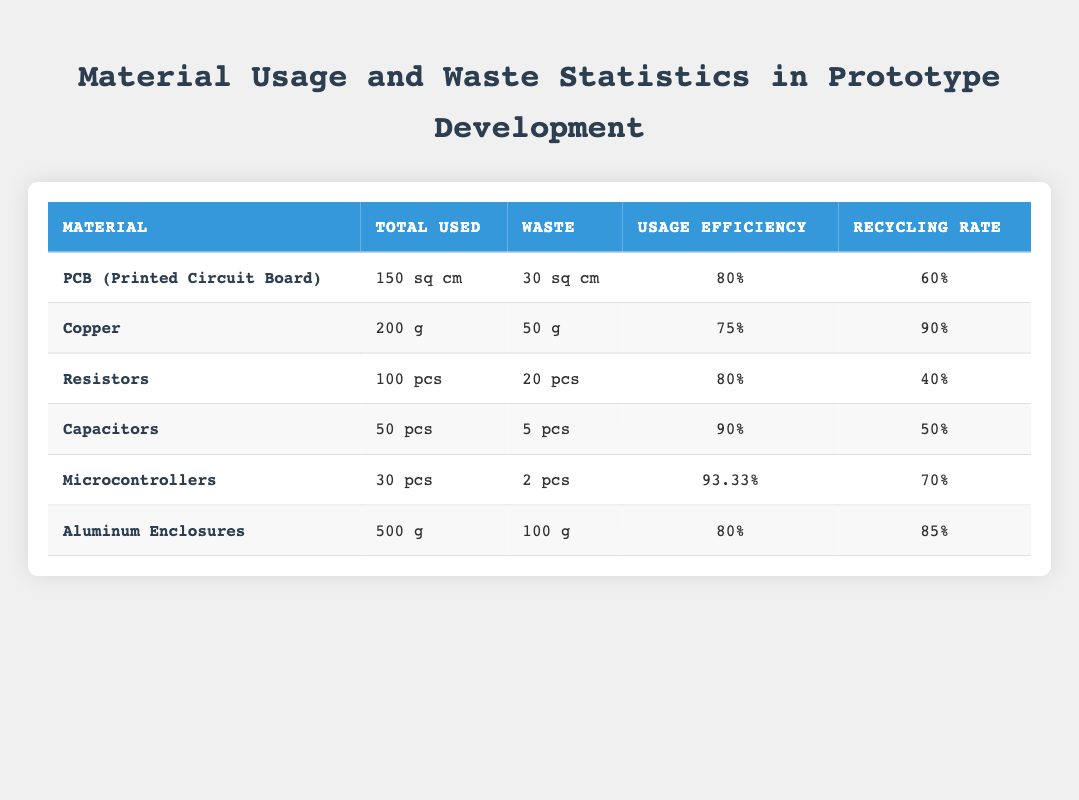What is the total used area for PCB in square centimeters? The table shows the total used area for PCB (Printed Circuit Board) as 150 sq cm in the respective row.
Answer: 150 sq cm What is the waste area for Copper? The waste area for Copper can be found directly in the table, where it states 50 g as the waste weight in the row for Copper.
Answer: 50 g Which material has the highest recycling rate? By comparing the recycling rates of each material listed in the table, Microcontrollers have a recycling rate of 70%, which is the highest among all the materials.
Answer: Microcontrollers Calculate the total waste weight for Aluminum Enclosures and Copper combined. The waste weight for Aluminum Enclosures is 100 g and for Copper, it is 50 g. Adding them together gives 100 + 50 = 150 g.
Answer: 150 g Is the usage efficiency for Capacitors greater than that for Resistors? The usage efficiency for Capacitors is 90% while for Resistors it is 80%. Since 90% is greater than 80%, the statement is true.
Answer: Yes What is the total number of waste components for Microcontrollers and Resistors combined? The waste count for Microcontrollers is 2, and for Resistors, it is 20. Adding them together gives 2 + 20 = 22.
Answer: 22 What percentage of PCB material was wasted? The waste area for PCB is 30 sq cm and total used area is 150 sq cm. The percentage wasted can be calculated as (30/150) * 100 = 20%.
Answer: 20% Is the usage efficiency of Microcontrollers above 90%? The table indicates that the usage efficiency for Microcontrollers is 93.33%, which is indeed above 90%. Therefore, the statement is true.
Answer: Yes Which material has the lowest recycling rate? By reviewing the recycling rates, Resistors have the lowest recycling rate at 40%, making them the material with the lowest rate.
Answer: Resistors 